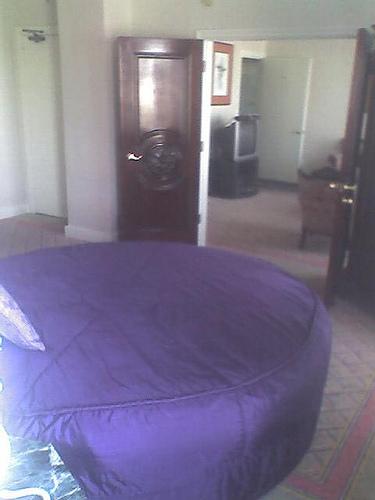Do you see any cleaning wipes in the photo?
Answer briefly. No. How many doors are open?
Write a very short answer. 2. What shape is this bed?
Write a very short answer. Round. What color is the bed?
Keep it brief. Blue. Is this someone's bedroom?
Give a very brief answer. Yes. 